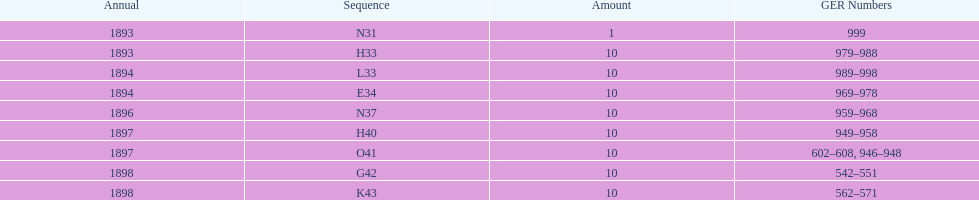What amount of time to the years span? 5 years. 